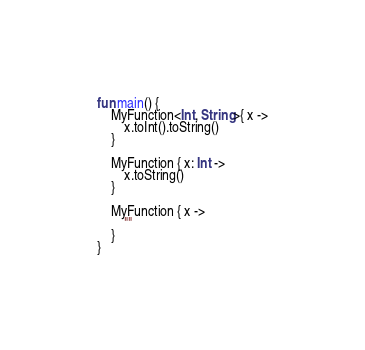Convert code to text. <code><loc_0><loc_0><loc_500><loc_500><_Kotlin_>
fun main() {
    MyFunction<Int, String>{ x ->
        x.toInt().toString()
    }

    MyFunction { x: Int ->
        x.toString()
    }

    MyFunction { x ->
        ""
    }
}
</code> 